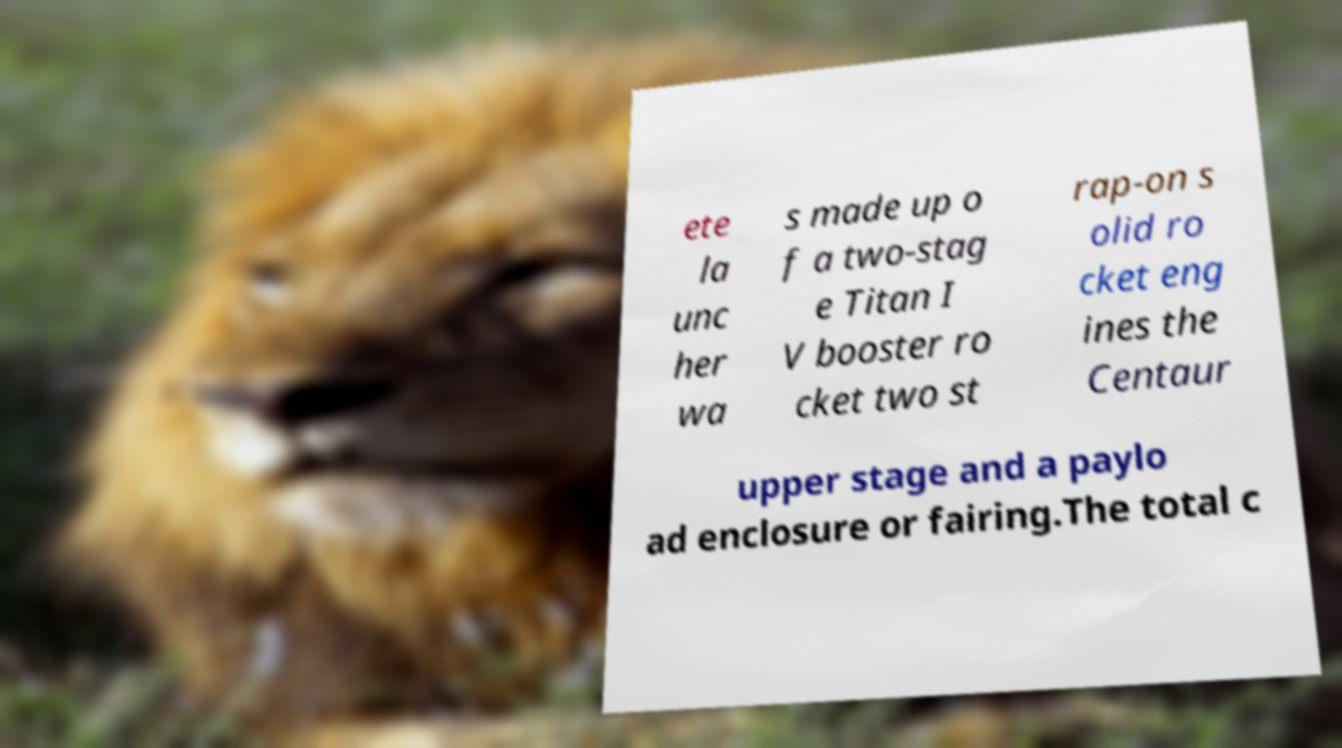Can you accurately transcribe the text from the provided image for me? ete la unc her wa s made up o f a two-stag e Titan I V booster ro cket two st rap-on s olid ro cket eng ines the Centaur upper stage and a paylo ad enclosure or fairing.The total c 